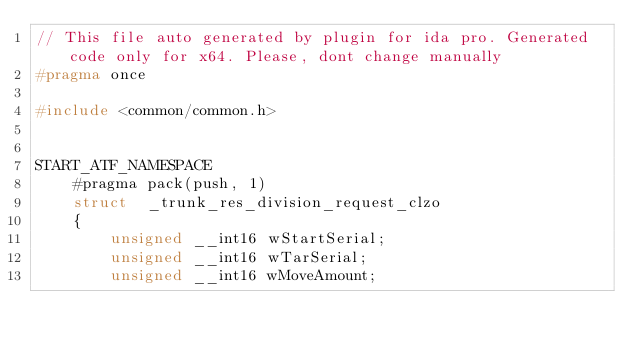Convert code to text. <code><loc_0><loc_0><loc_500><loc_500><_C++_>// This file auto generated by plugin for ida pro. Generated code only for x64. Please, dont change manually
#pragma once

#include <common/common.h>


START_ATF_NAMESPACE
    #pragma pack(push, 1)
    struct  _trunk_res_division_request_clzo
    {
        unsigned __int16 wStartSerial;
        unsigned __int16 wTarSerial;
        unsigned __int16 wMoveAmount;</code> 